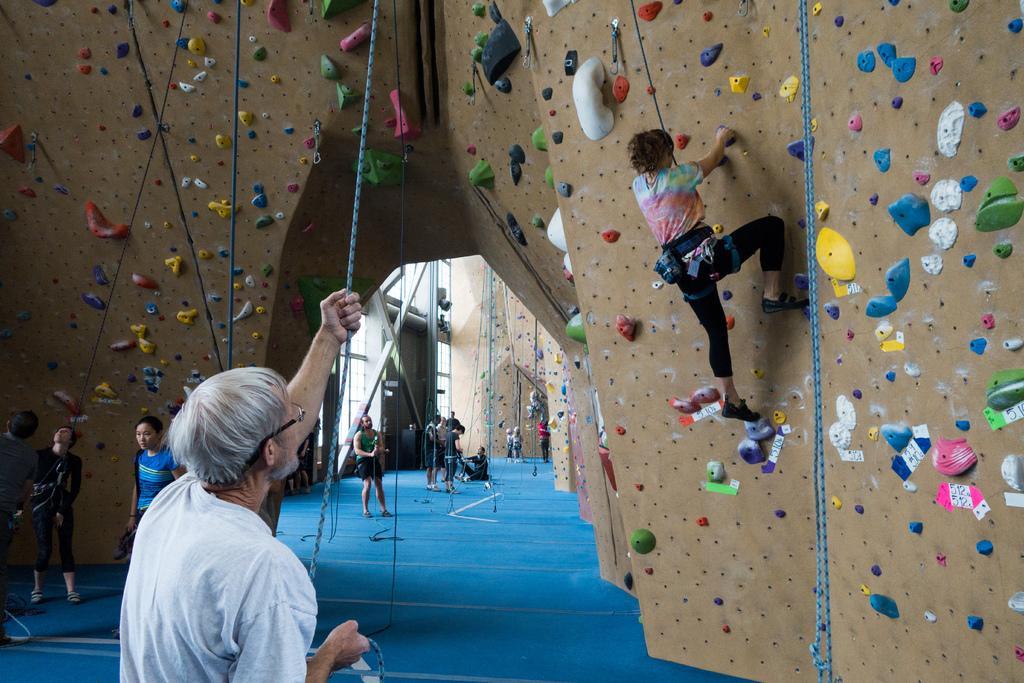How would you summarize this image in a sentence or two? In the picture there are Bouldering walls and few people were climbing those walls and in front of those walls some people were standing by holding the ropes. 